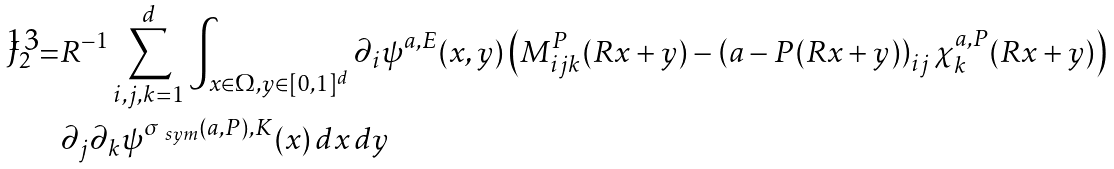Convert formula to latex. <formula><loc_0><loc_0><loc_500><loc_500>J _ { 2 } = & R ^ { - 1 } \sum _ { i , j , k = 1 } ^ { d } \int _ { x \in \Omega , y \in [ 0 , 1 ] ^ { d } } \partial _ { i } \psi ^ { a , E } ( x , y ) \left ( M ^ { P } _ { i j k } ( R x + y ) - \left ( a - P ( R x + y ) \right ) _ { i j } \chi ^ { a , P } _ { k } ( R x + y ) \right ) \\ & \partial _ { j } \partial _ { k } \psi ^ { \sigma _ { \ s y m } ( a , P ) , K } ( x ) \, d x \, d y</formula> 